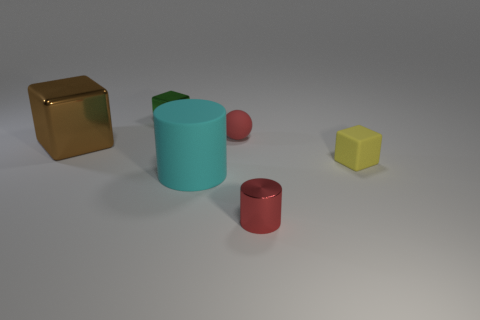Is there a green object of the same size as the ball?
Keep it short and to the point. Yes. What is the size of the red object that is in front of the brown metallic block?
Your answer should be very brief. Small. What is the size of the green metal cube?
Offer a terse response. Small. How many cylinders are either tiny yellow things or tiny red matte things?
Provide a succinct answer. 0. There is a brown block that is the same material as the tiny cylinder; what is its size?
Make the answer very short. Large. How many tiny rubber cubes are the same color as the small cylinder?
Provide a succinct answer. 0. Are there any large metal cubes in front of the green cube?
Provide a short and direct response. Yes. Does the big metallic thing have the same shape as the small red object behind the large cyan rubber object?
Ensure brevity in your answer.  No. What number of things are rubber things that are on the right side of the tiny metallic cylinder or small rubber blocks?
Offer a very short reply. 1. How many things are both right of the cyan rubber thing and in front of the small red matte thing?
Your answer should be compact. 2. 